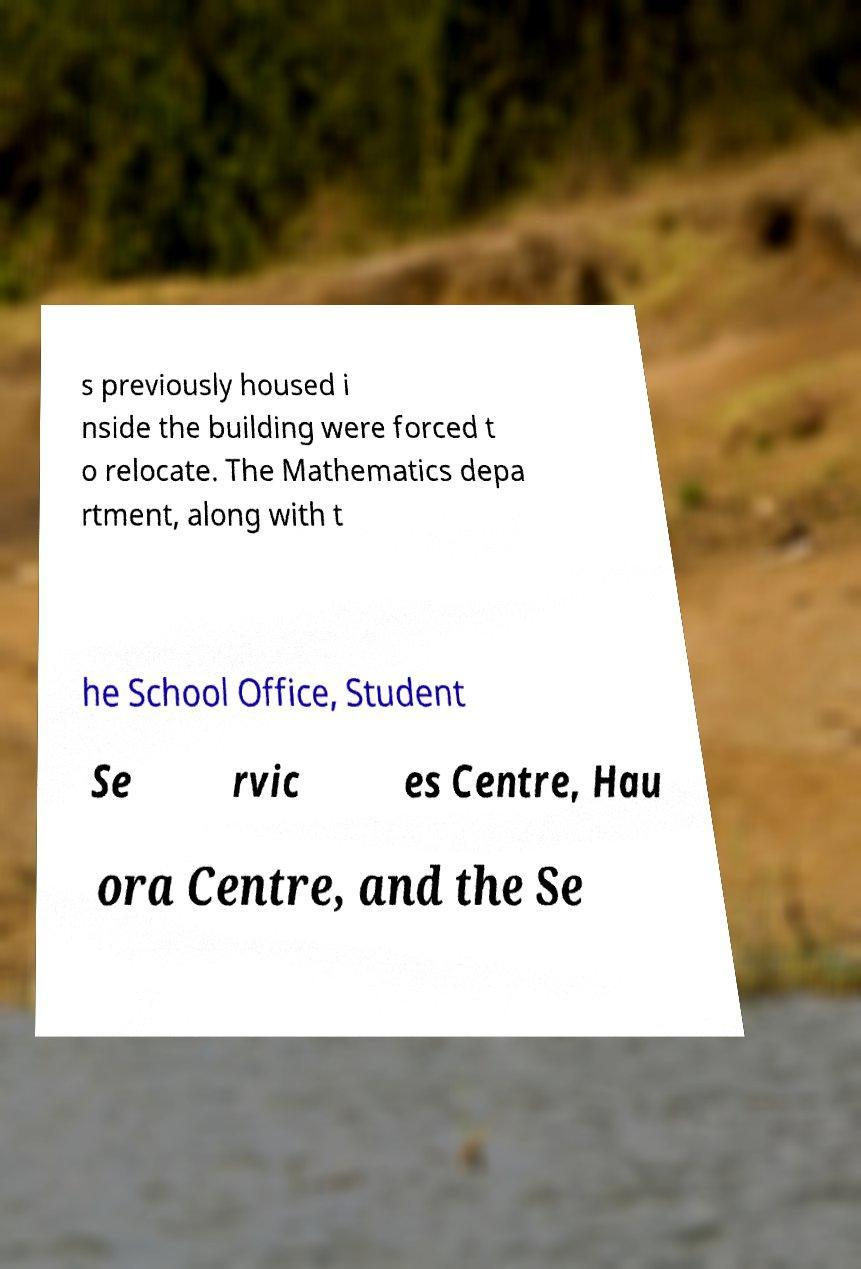There's text embedded in this image that I need extracted. Can you transcribe it verbatim? s previously housed i nside the building were forced t o relocate. The Mathematics depa rtment, along with t he School Office, Student Se rvic es Centre, Hau ora Centre, and the Se 